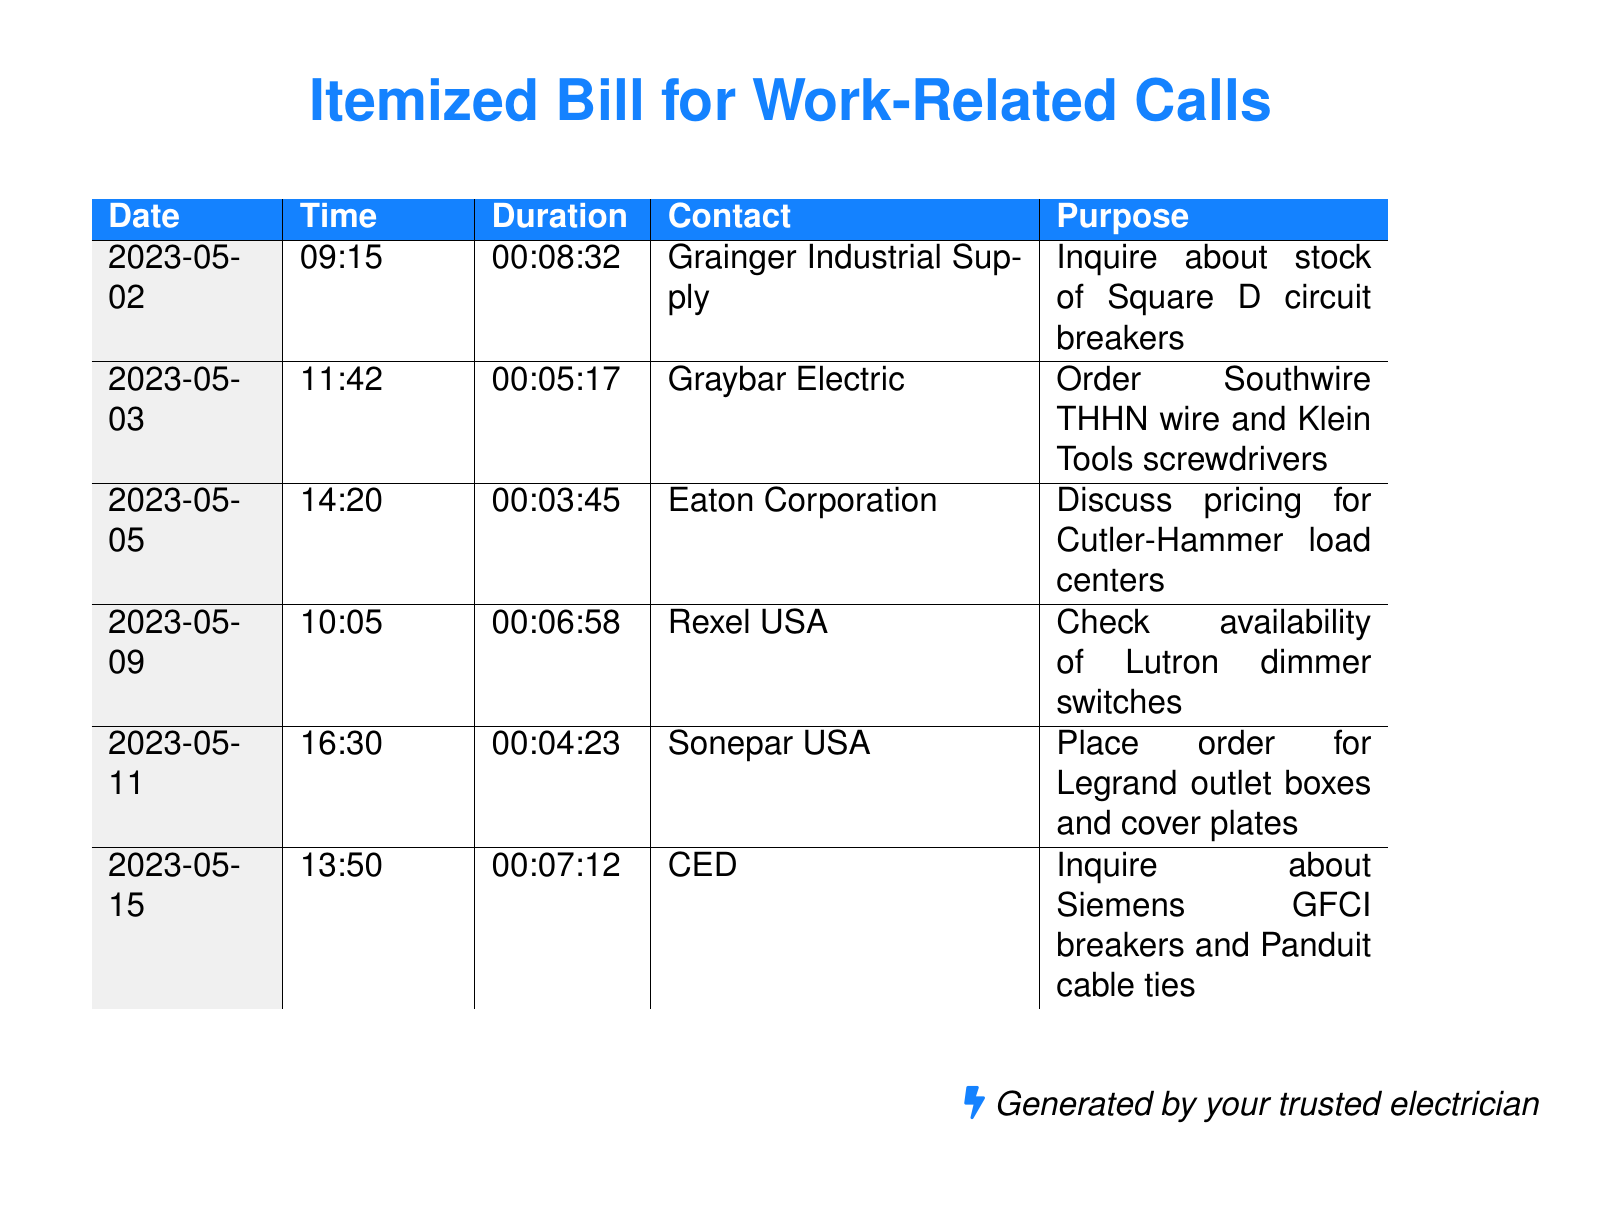What is the date of the longest call? The longest call is the one that lasts 00:08:32 on May 2nd, 2023.
Answer: 2023-05-02 Who inquired about Lutron dimmer switches? The inquiry about Lutron dimmer switches was made to Rexel USA on May 9th, 2023.
Answer: Rexel USA How many calls were made to Grainger Industrial Supply? There was only one call made to Grainger Industrial Supply as listed in the document.
Answer: 1 What is the total duration of calls to Sonepar USA? The document shows one call to Sonepar USA, which lasts for 00:04:23.
Answer: 00:04:23 What was ordered from Graybar Electric? The order placed with Graybar Electric includes Southwire THHN wire and Klein Tools screwdrivers.
Answer: Southwire THHN wire and Klein Tools screwdrivers Which supplier was contacted on May 5th? On May 5th, 2023, Eaton Corporation was contacted regarding pricing.
Answer: Eaton Corporation What type of equipment was discussed with Eaton Corporation? The discussion was about Cutler-Hammer load centers.
Answer: Cutler-Hammer load centers Who provided the telephone records document? The records were generated by "your trusted electrician."
Answer: Your trusted electrician What is the total number of calls listed in the document? There are a total of six calls listed in the document.
Answer: 6 